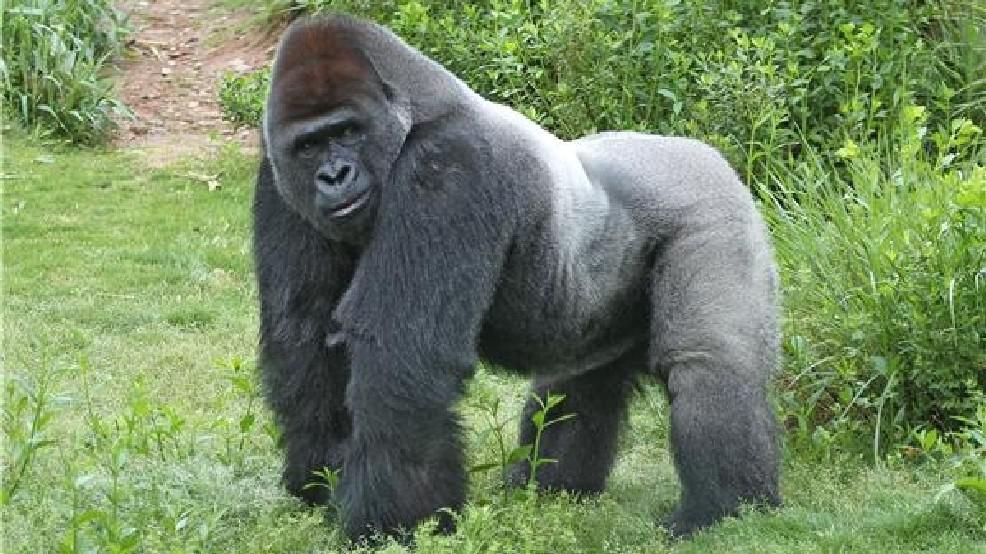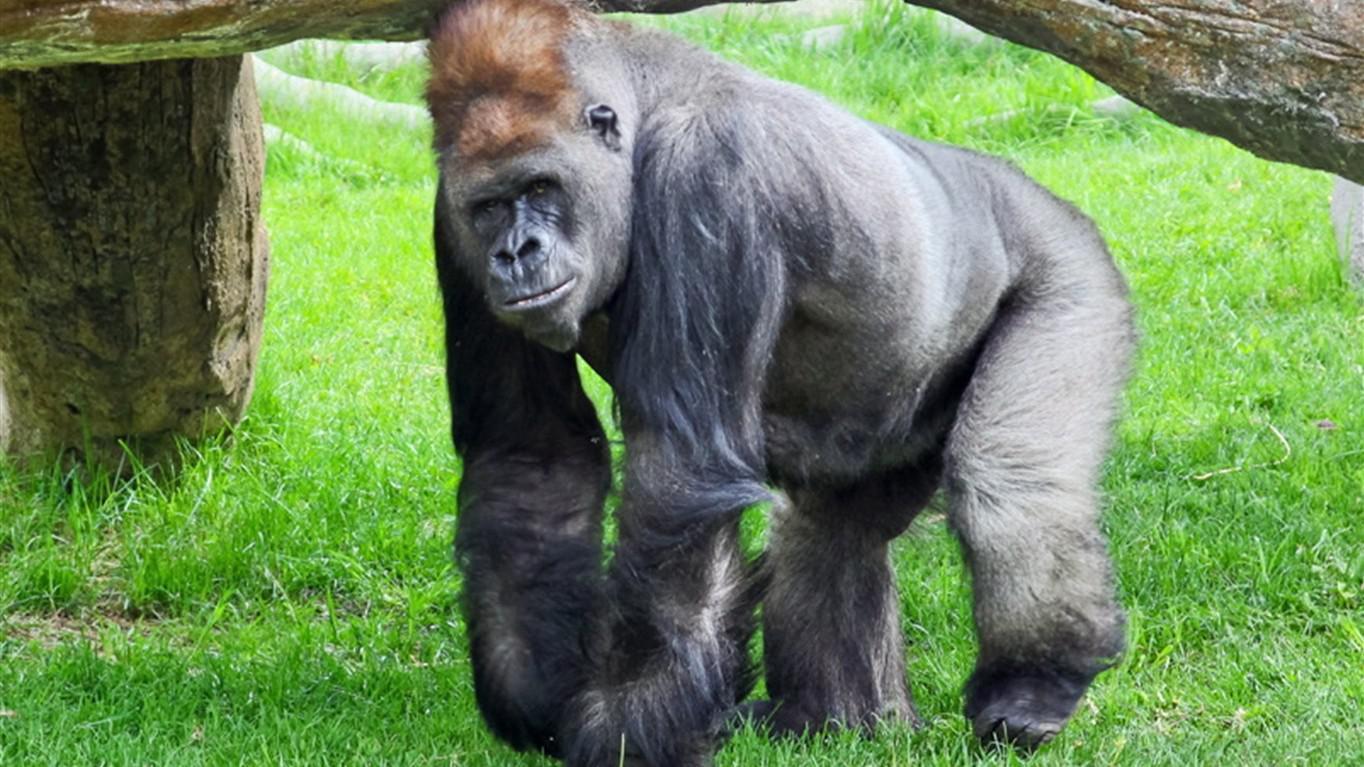The first image is the image on the left, the second image is the image on the right. Evaluate the accuracy of this statement regarding the images: "A single primate is hunched over on all fours in the grass in each image.". Is it true? Answer yes or no. Yes. The first image is the image on the left, the second image is the image on the right. Evaluate the accuracy of this statement regarding the images: "All gorillas are standing on all fours, and no image contains more than one gorilla.". Is it true? Answer yes or no. Yes. 